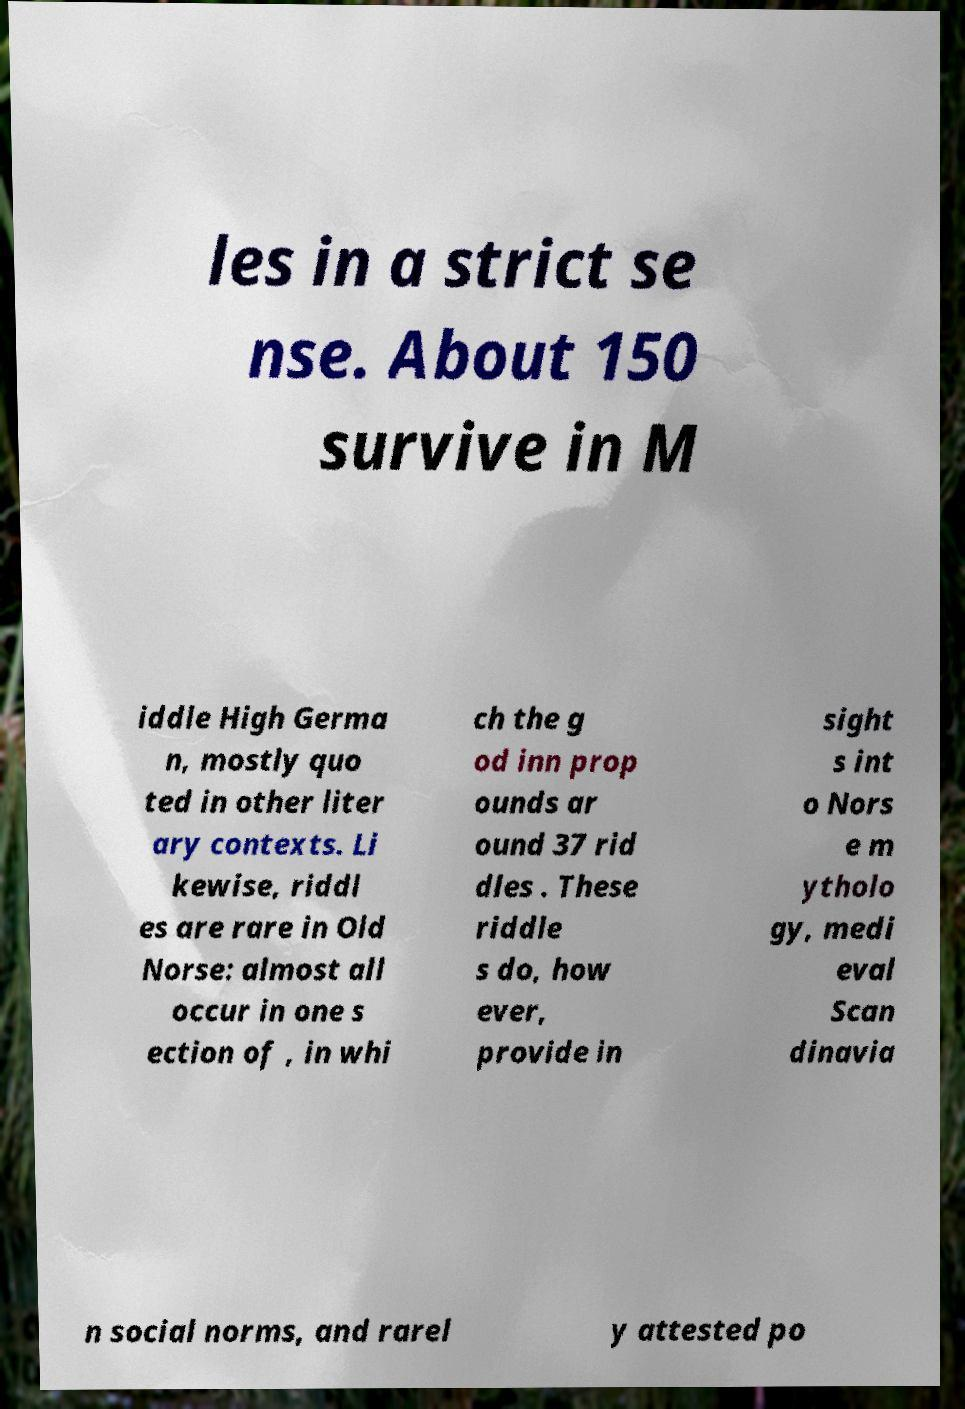Please identify and transcribe the text found in this image. les in a strict se nse. About 150 survive in M iddle High Germa n, mostly quo ted in other liter ary contexts. Li kewise, riddl es are rare in Old Norse: almost all occur in one s ection of , in whi ch the g od inn prop ounds ar ound 37 rid dles . These riddle s do, how ever, provide in sight s int o Nors e m ytholo gy, medi eval Scan dinavia n social norms, and rarel y attested po 